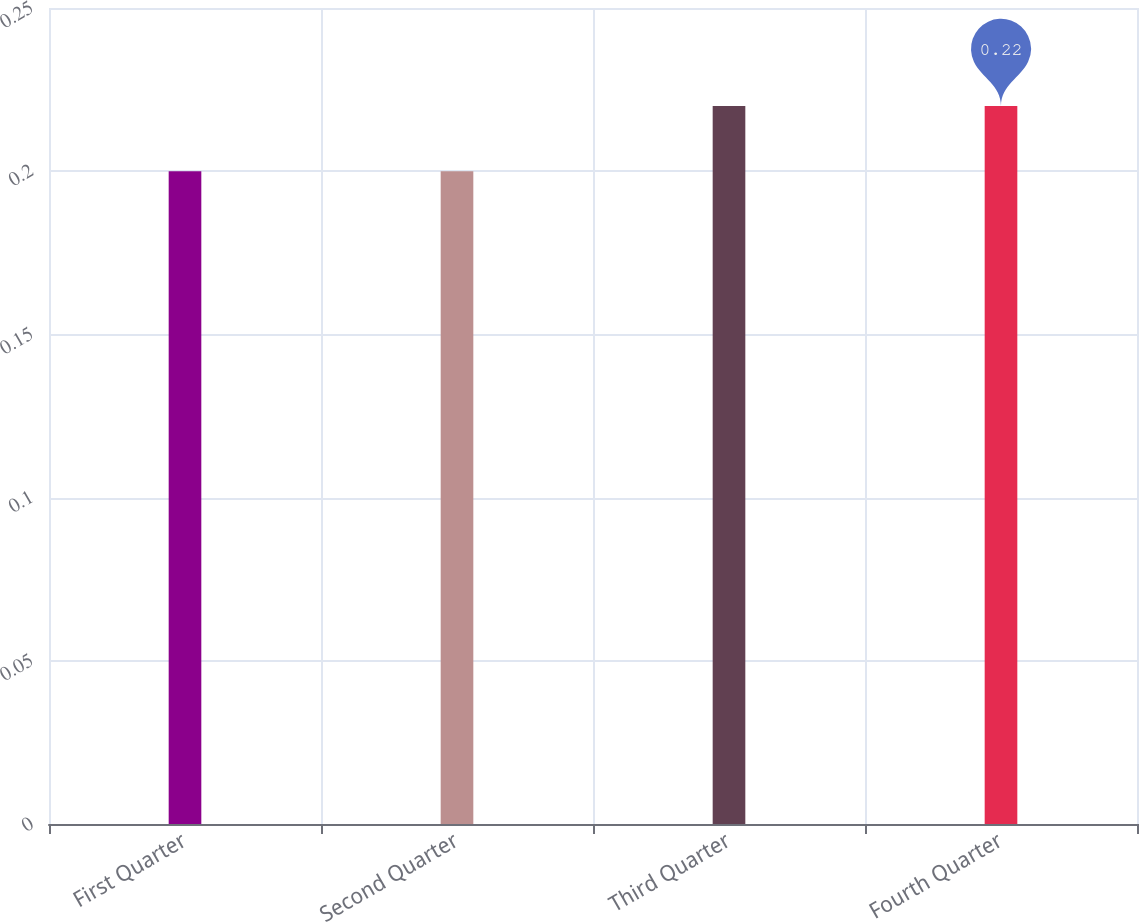Convert chart. <chart><loc_0><loc_0><loc_500><loc_500><bar_chart><fcel>First Quarter<fcel>Second Quarter<fcel>Third Quarter<fcel>Fourth Quarter<nl><fcel>0.2<fcel>0.2<fcel>0.22<fcel>0.22<nl></chart> 